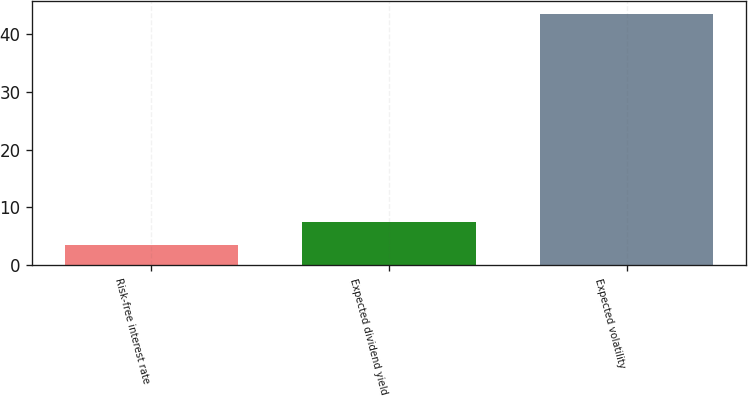<chart> <loc_0><loc_0><loc_500><loc_500><bar_chart><fcel>Risk-free interest rate<fcel>Expected dividend yield<fcel>Expected volatility<nl><fcel>3.5<fcel>7.5<fcel>43.5<nl></chart> 